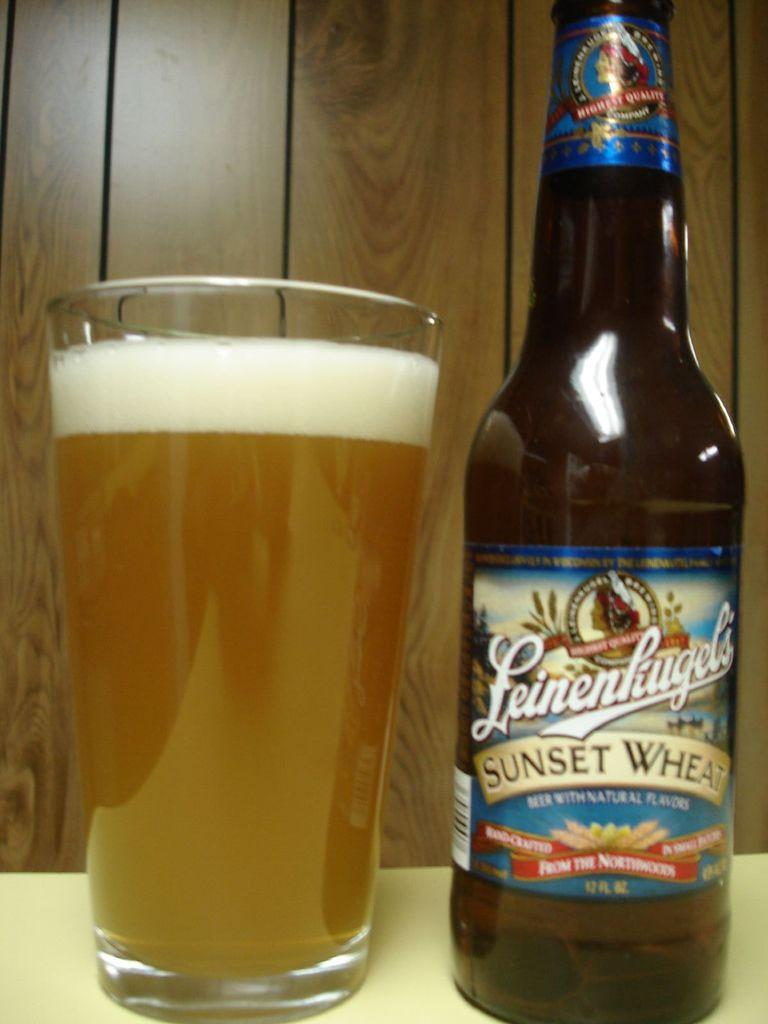<image>
Share a concise interpretation of the image provided. A glass with Leinenhiugel's sunset wheet beer poured into it. 